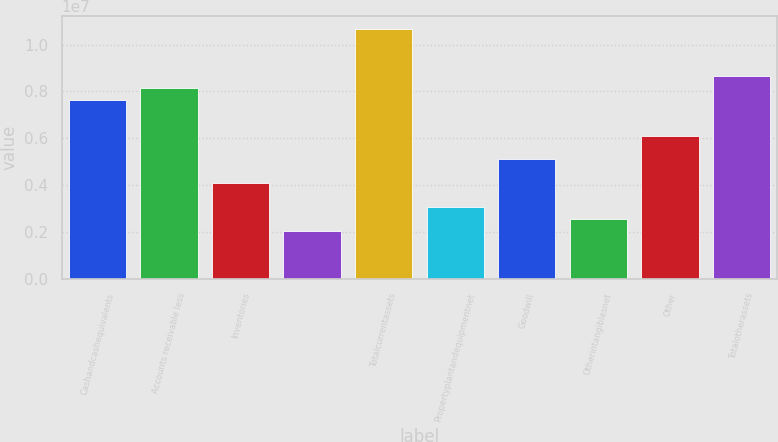Convert chart. <chart><loc_0><loc_0><loc_500><loc_500><bar_chart><fcel>Cashandcashequivalents<fcel>Accounts receivable less<fcel>Inventories<fcel>Unnamed: 3<fcel>Totalcurrentassets<fcel>Propertyplantandequipmentnet<fcel>Goodwill<fcel>Otherintangiblesnet<fcel>Other<fcel>Totalotherassets<nl><fcel>7.6257e+06<fcel>8.13256e+06<fcel>4.07763e+06<fcel>2.05017e+06<fcel>1.06669e+07<fcel>3.0639e+06<fcel>5.09137e+06<fcel>2.55704e+06<fcel>6.1051e+06<fcel>8.63943e+06<nl></chart> 